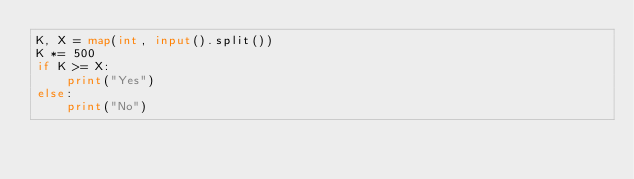<code> <loc_0><loc_0><loc_500><loc_500><_Python_>K, X = map(int, input().split())
K *= 500
if K >= X:
    print("Yes")
else:
    print("No")
</code> 